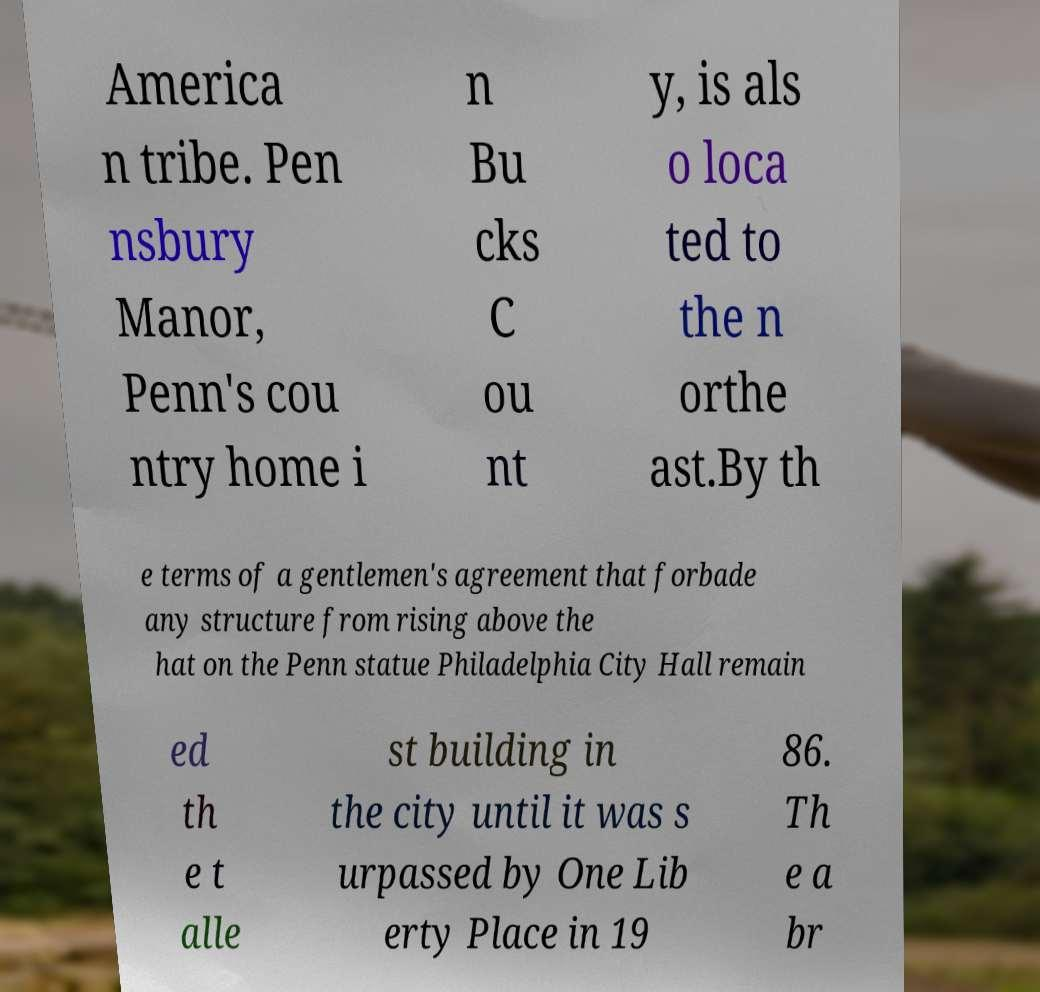Could you extract and type out the text from this image? America n tribe. Pen nsbury Manor, Penn's cou ntry home i n Bu cks C ou nt y, is als o loca ted to the n orthe ast.By th e terms of a gentlemen's agreement that forbade any structure from rising above the hat on the Penn statue Philadelphia City Hall remain ed th e t alle st building in the city until it was s urpassed by One Lib erty Place in 19 86. Th e a br 